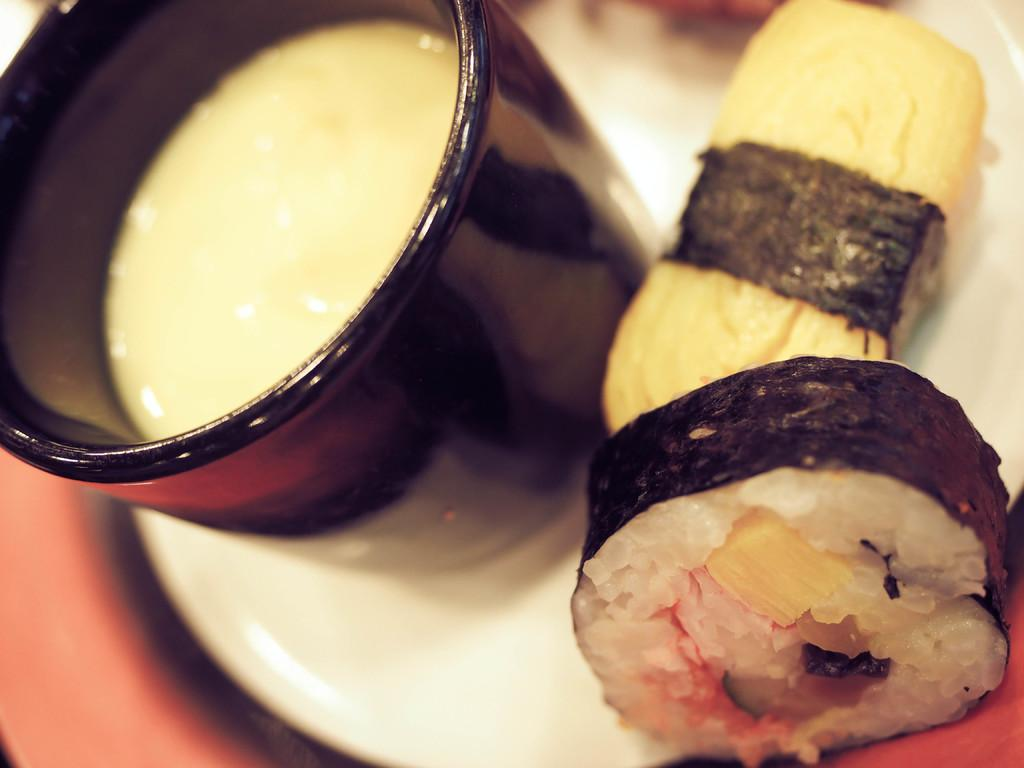What is placed on the plate in the image? There are eatable things placed on a plate in the image. Can you describe the black bowl in the image? There is a black bowl with liquid in the image. Where is the monkey sitting in the image? There is no monkey present in the image. What type of cloud is visible in the image? There is no cloud visible in the image. 